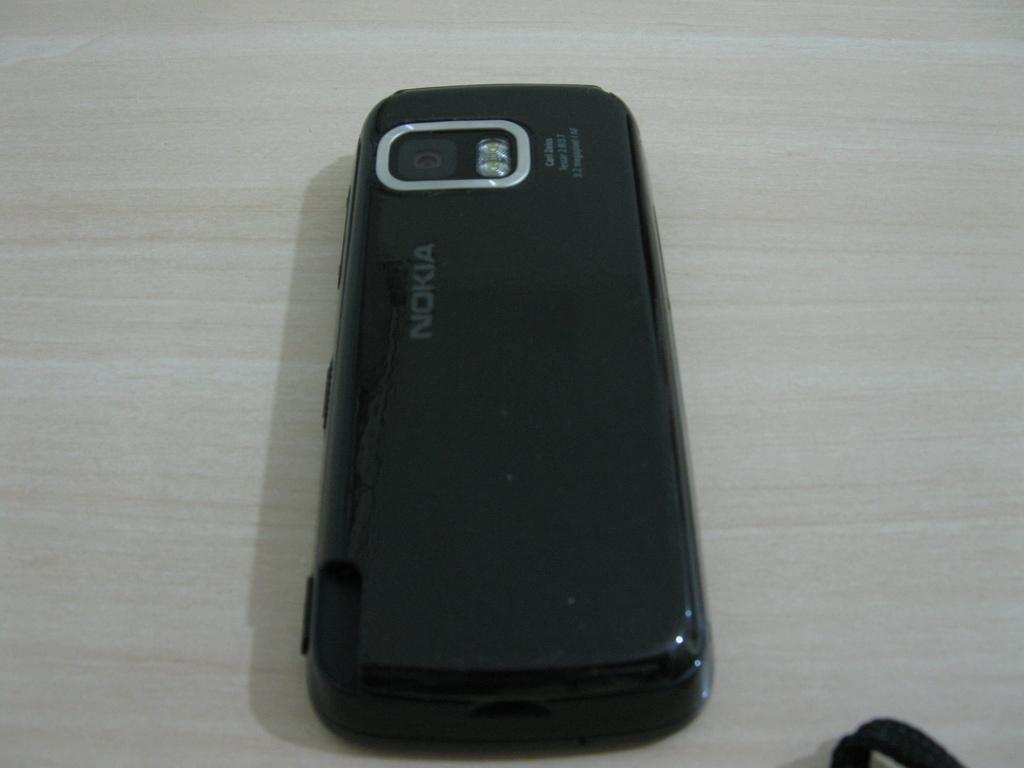<image>
Provide a brief description of the given image. A black Nokia phone laying on a light colored table top. 